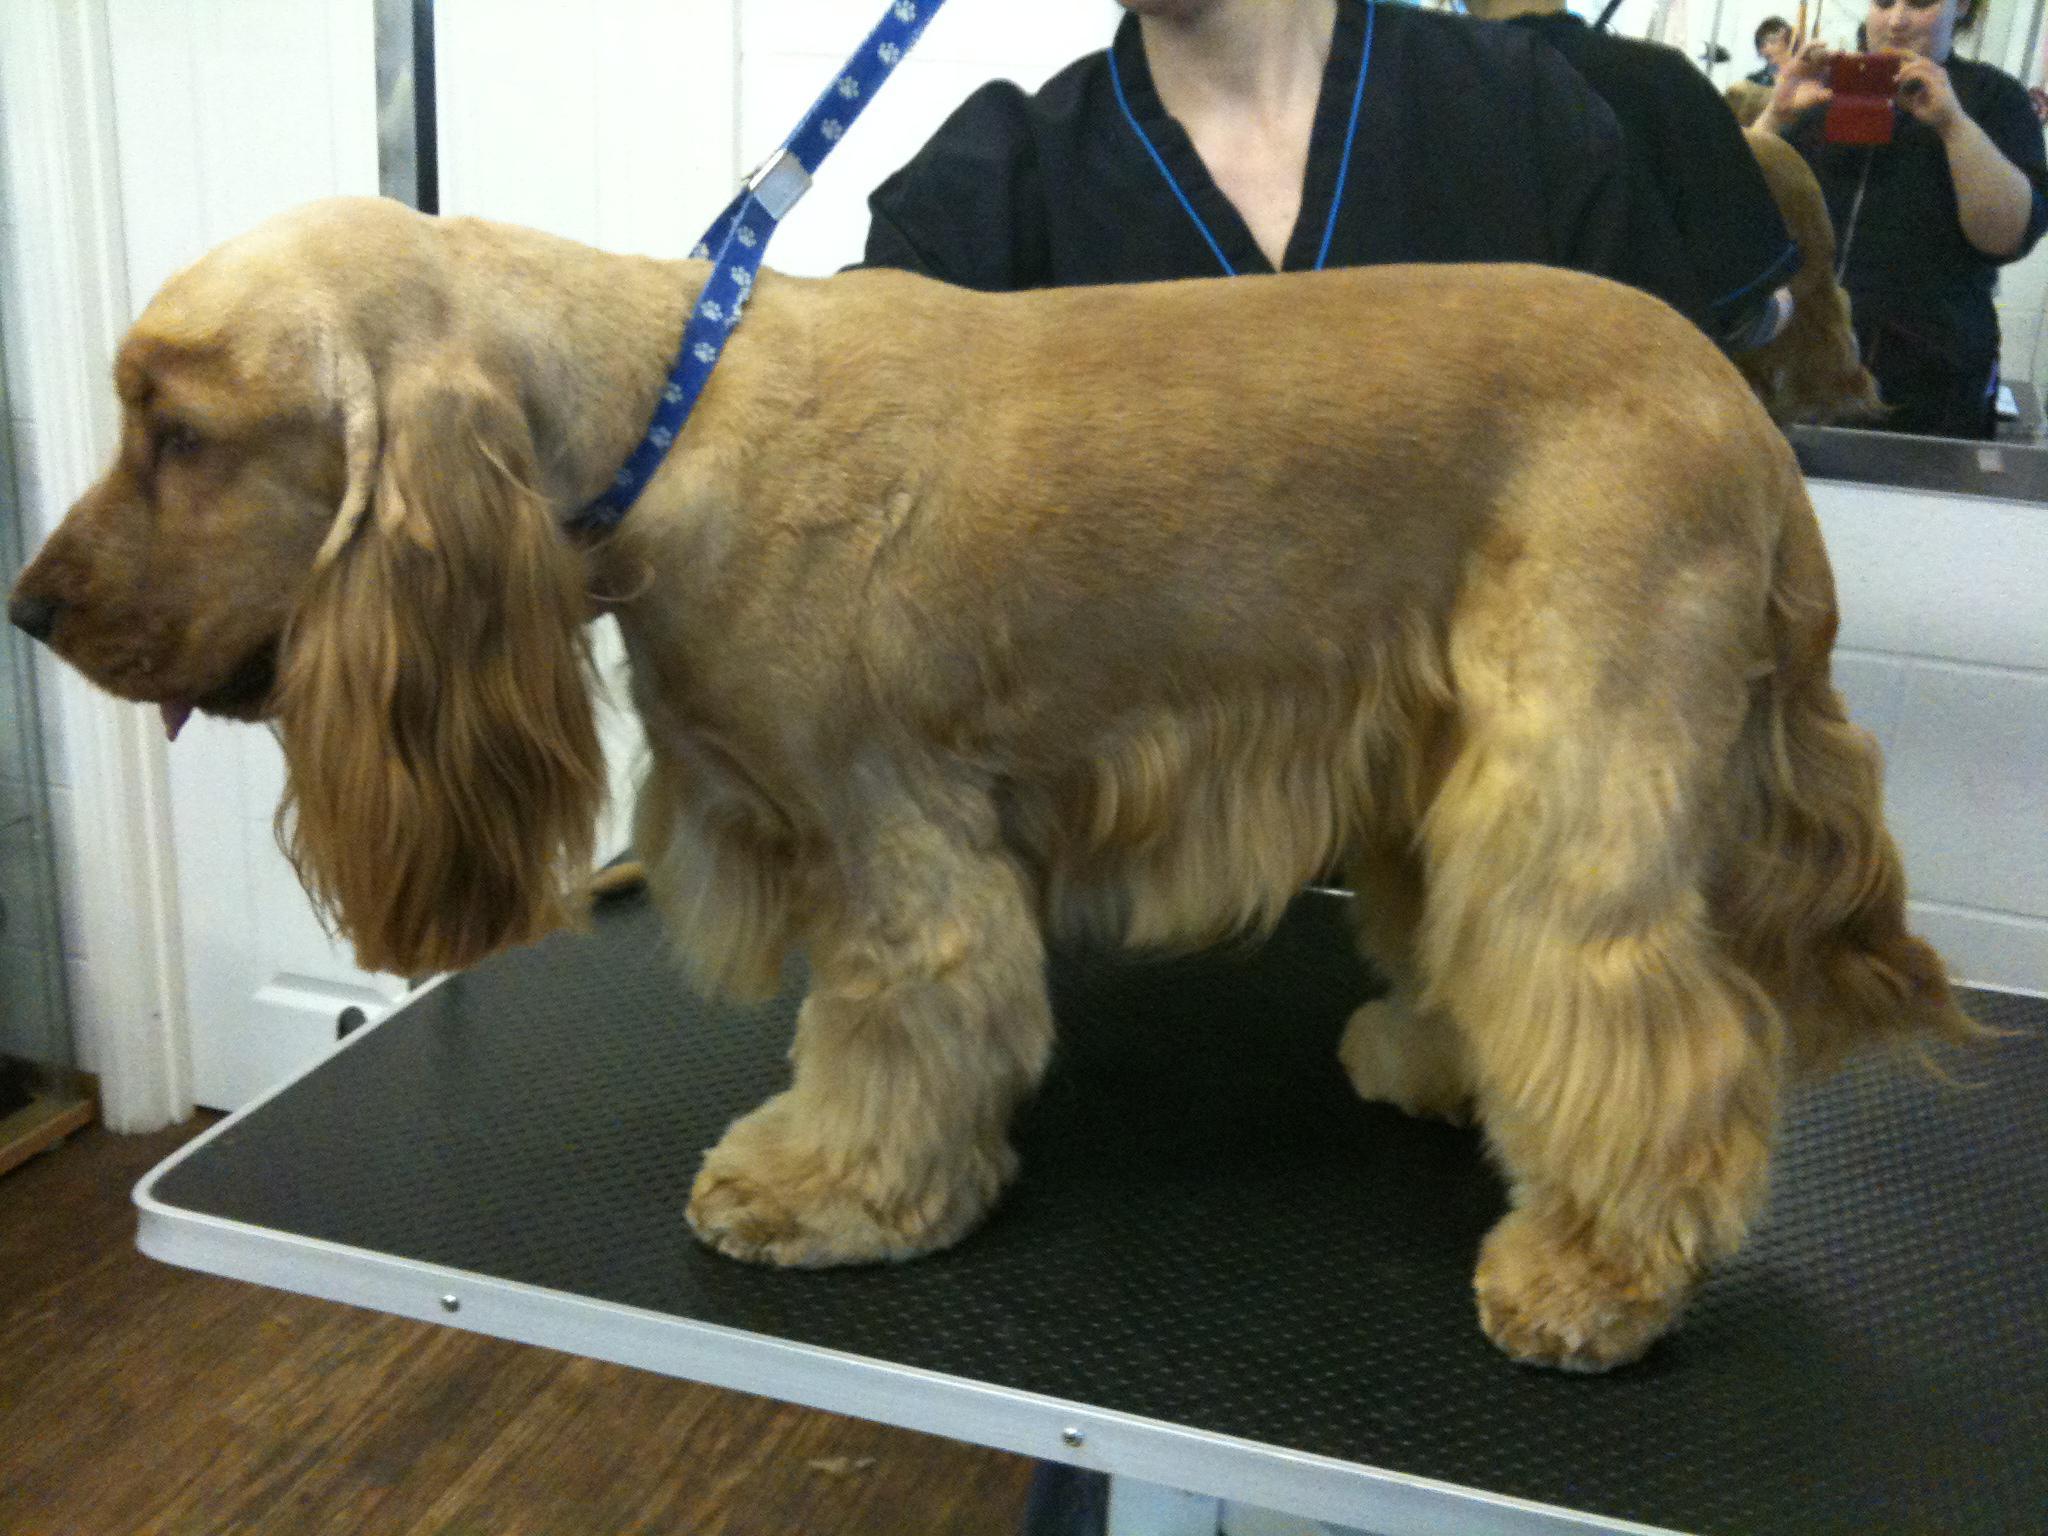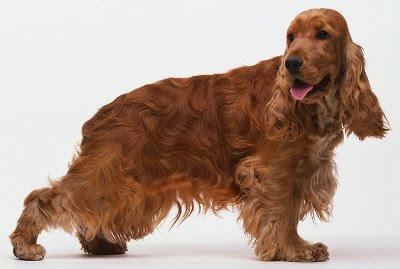The first image is the image on the left, the second image is the image on the right. Considering the images on both sides, is "Each image contains a single spaniel dog, and the dogs in the left and right images have similar type body poses." valid? Answer yes or no. Yes. 